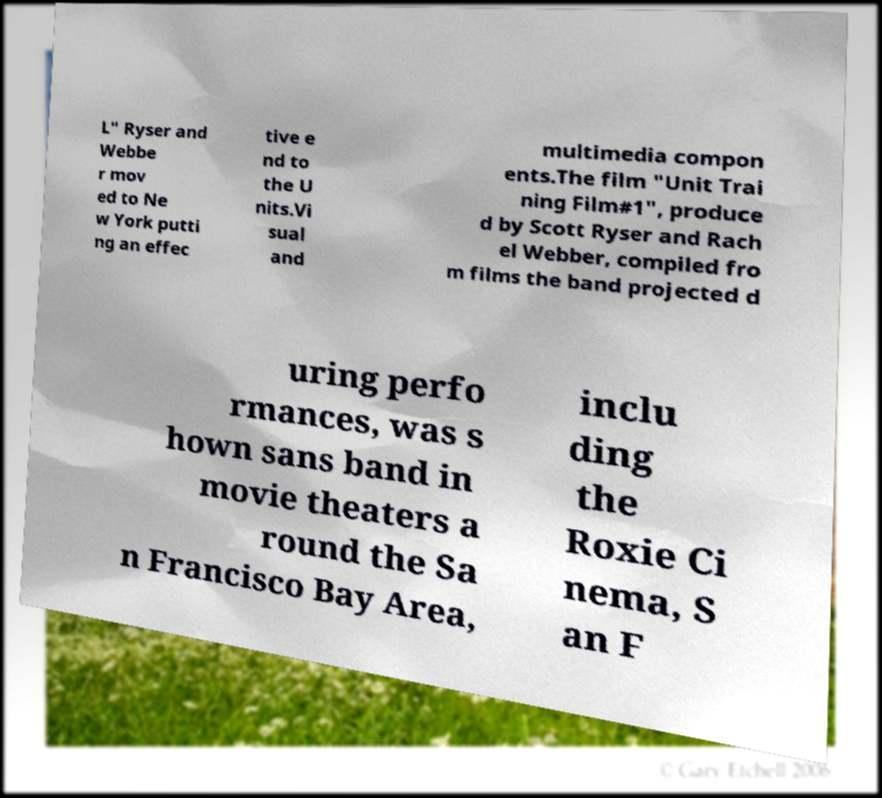I need the written content from this picture converted into text. Can you do that? L" Ryser and Webbe r mov ed to Ne w York putti ng an effec tive e nd to the U nits.Vi sual and multimedia compon ents.The film "Unit Trai ning Film#1", produce d by Scott Ryser and Rach el Webber, compiled fro m films the band projected d uring perfo rmances, was s hown sans band in movie theaters a round the Sa n Francisco Bay Area, inclu ding the Roxie Ci nema, S an F 